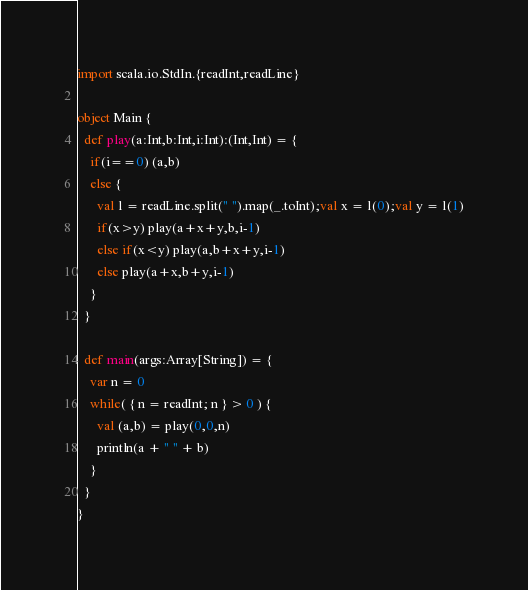<code> <loc_0><loc_0><loc_500><loc_500><_Scala_>import scala.io.StdIn.{readInt,readLine}

object Main {
  def play(a:Int,b:Int,i:Int):(Int,Int) = {
    if(i==0) (a,b)
    else {
      val l = readLine.split(" ").map(_.toInt);val x = l(0);val y = l(1)
      if(x>y) play(a+x+y,b,i-1)
      else if(x<y) play(a,b+x+y,i-1)
      else play(a+x,b+y,i-1)
    }
  }

  def main(args:Array[String]) = {
    var n = 0
    while( { n = readInt; n } > 0 ) {
      val (a,b) = play(0,0,n)
      println(a + " " + b)
    }
  }
}</code> 